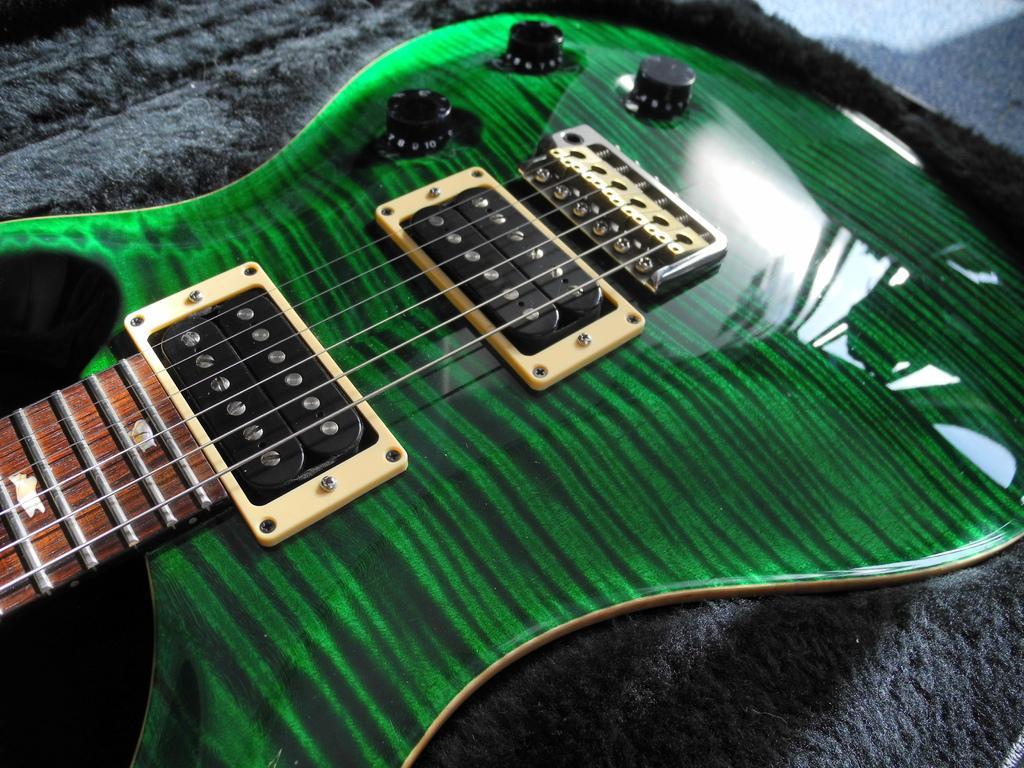Please provide a concise description of this image. In the image there is a guitar which is in green color and it is also having strings, it is placed on a mat. 